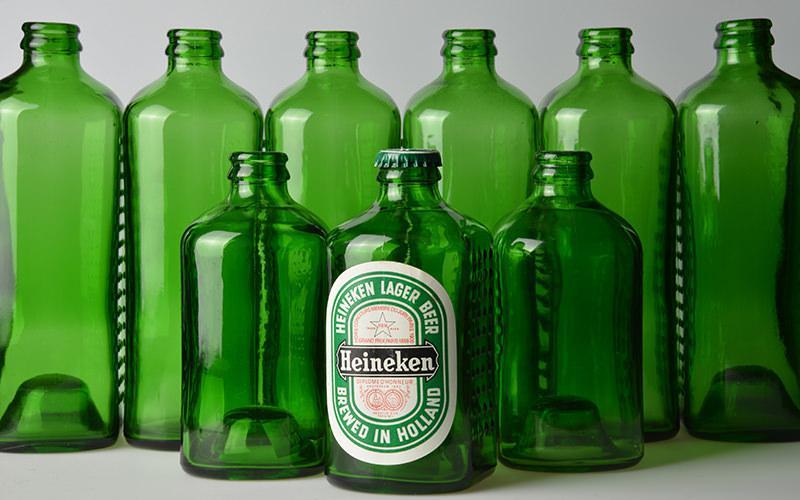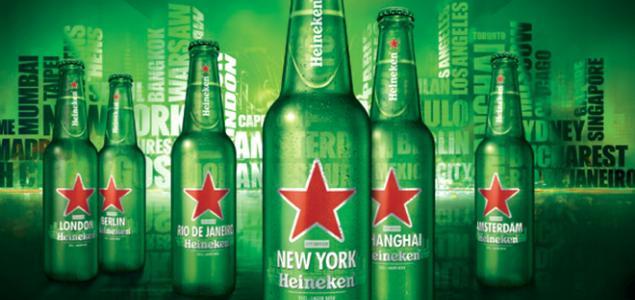The first image is the image on the left, the second image is the image on the right. Analyze the images presented: Is the assertion "An image shows one stand-out bottle with its label clearly showing, amid at least a half dozen green bottles." valid? Answer yes or no. Yes. The first image is the image on the left, the second image is the image on the right. Analyze the images presented: Is the assertion "In at least one image there are six green beer bottles." valid? Answer yes or no. Yes. 